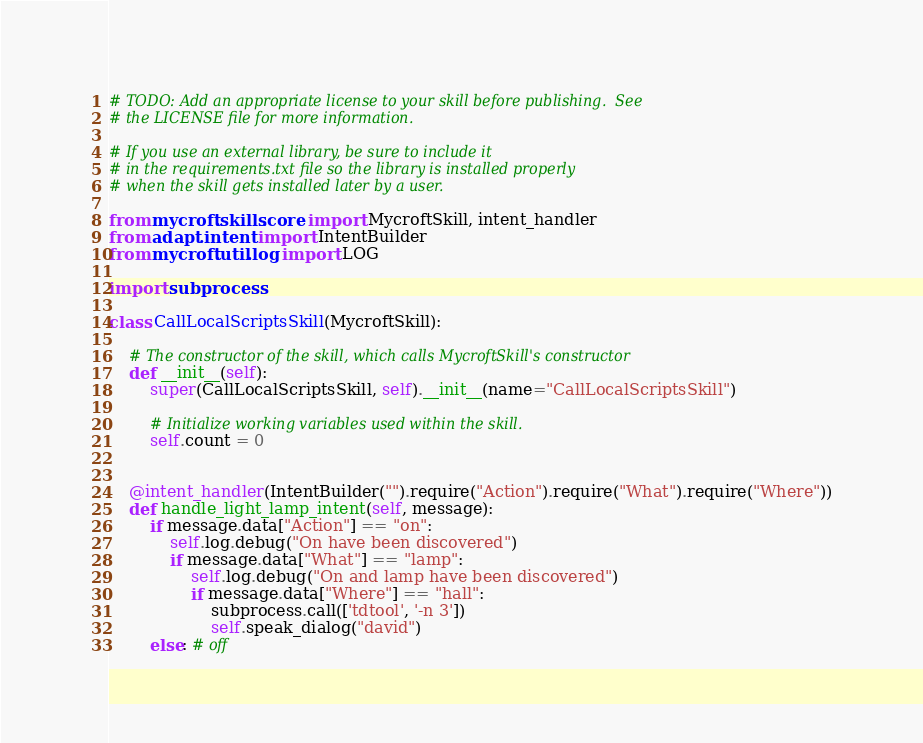<code> <loc_0><loc_0><loc_500><loc_500><_Python_># TODO: Add an appropriate license to your skill before publishing.  See
# the LICENSE file for more information.

# If you use an external library, be sure to include it
# in the requirements.txt file so the library is installed properly
# when the skill gets installed later by a user.

from mycroft.skills.core import MycroftSkill, intent_handler
from adapt.intent import IntentBuilder
from mycroft.util.log import LOG

import subprocess

class CallLocalScriptsSkill(MycroftSkill):

    # The constructor of the skill, which calls MycroftSkill's constructor
    def __init__(self):
        super(CallLocalScriptsSkill, self).__init__(name="CallLocalScriptsSkill")
        
        # Initialize working variables used within the skill.
        self.count = 0


    @intent_handler(IntentBuilder("").require("Action").require("What").require("Where"))
    def handle_light_lamp_intent(self, message):
        if message.data["Action"] == "on":
            self.log.debug("On have been discovered")
            if message.data["What"] == "lamp":
                self.log.debug("On and lamp have been discovered")
                if message.data["Where"] == "hall":
                    subprocess.call(['tdtool', '-n 3'])
                    self.speak_dialog("david")
        else: # off</code> 